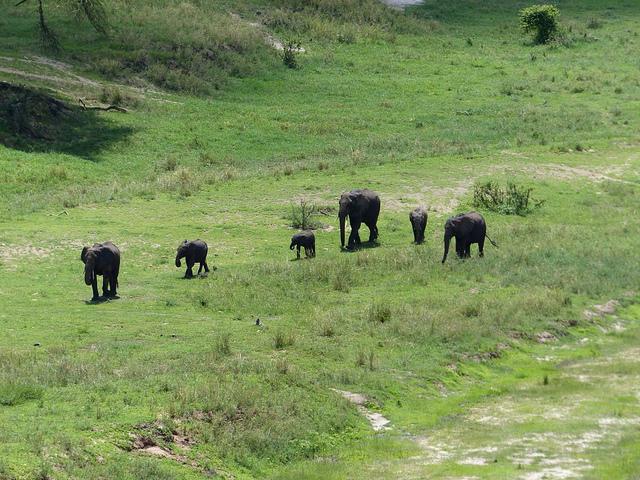How many animals are walking?
Be succinct. 6. Are the animals escaping?
Keep it brief. No. Is there a person in the photo?
Be succinct. No. Can this animal swim?
Keep it brief. Yes. What is in the picture of this?
Write a very short answer. Elephants. 